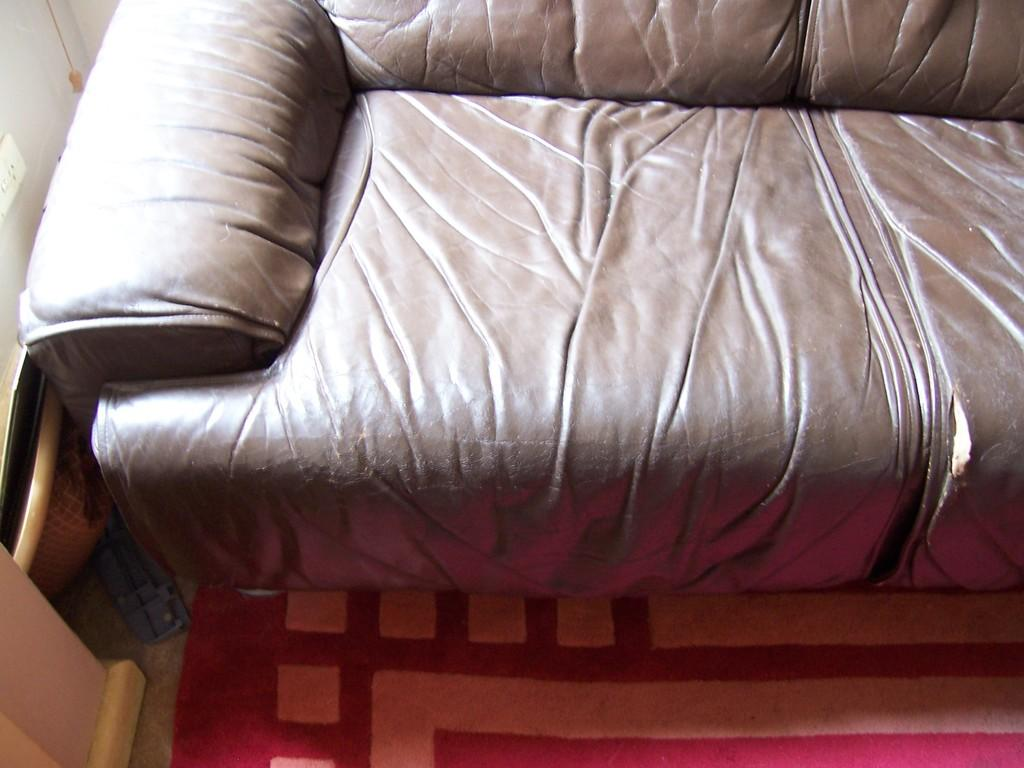What type of furniture is in the image? There is a sofa in the image. What is on the floor in the image? There is a carpet on the floor in the image. Where is the switch board located in the image? The switch board is on the left side of the image. What is located near the switch board? There is a basket on the left side of the image. What type of organization is responsible for the camera in the image? There is no camera present in the image, so it is not possible to determine the organization responsible for it. 